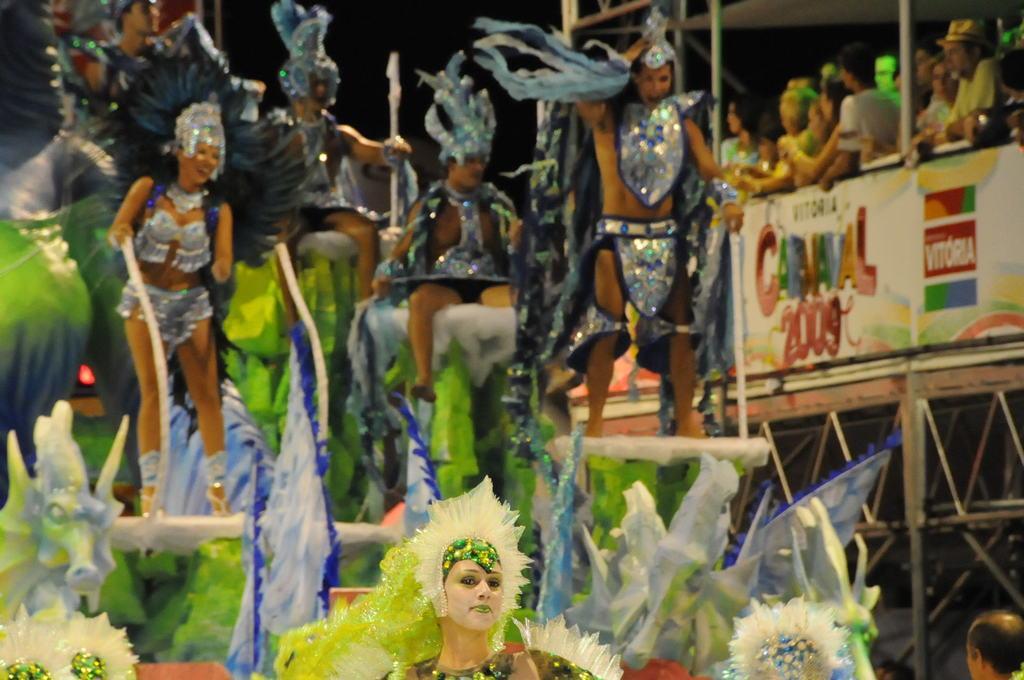How would you summarize this image in a sentence or two? In this picture, we can see a few people in a costume, and a few are holding some objects, we can see poles, floor, poster with some text, and the dark sky. 